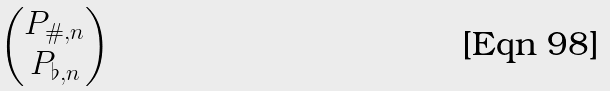<formula> <loc_0><loc_0><loc_500><loc_500>\begin{pmatrix} P _ { \# , n } \\ P _ { \flat , n } \end{pmatrix}</formula> 